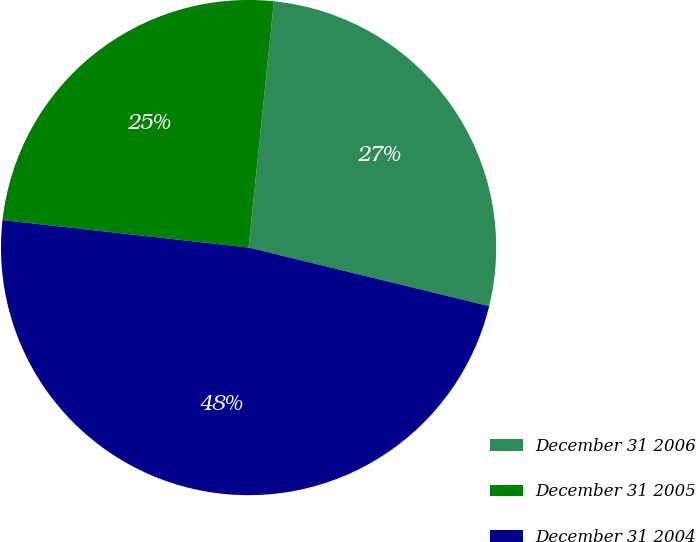Convert chart. <chart><loc_0><loc_0><loc_500><loc_500><pie_chart><fcel>December 31 2006<fcel>December 31 2005<fcel>December 31 2004<nl><fcel>27.17%<fcel>24.86%<fcel>47.97%<nl></chart> 